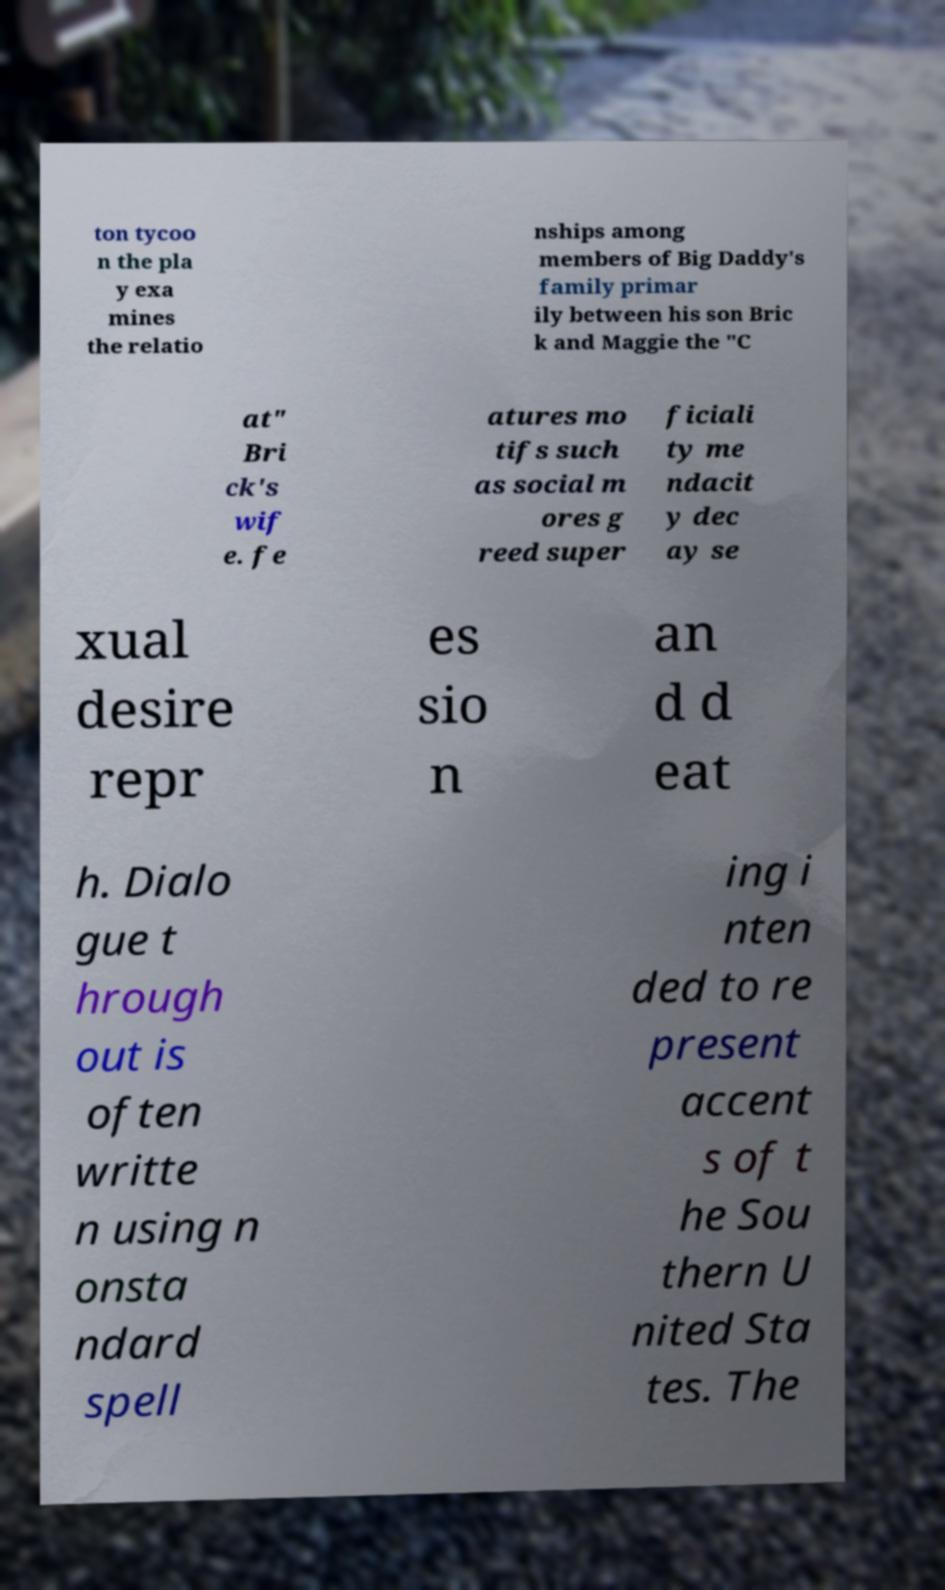What messages or text are displayed in this image? I need them in a readable, typed format. ton tycoo n the pla y exa mines the relatio nships among members of Big Daddy's family primar ily between his son Bric k and Maggie the "C at" Bri ck's wif e. fe atures mo tifs such as social m ores g reed super ficiali ty me ndacit y dec ay se xual desire repr es sio n an d d eat h. Dialo gue t hrough out is often writte n using n onsta ndard spell ing i nten ded to re present accent s of t he Sou thern U nited Sta tes. The 